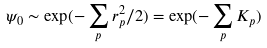<formula> <loc_0><loc_0><loc_500><loc_500>\psi _ { 0 } \sim \exp ( - \sum _ { p } r _ { p } ^ { 2 } / 2 ) = \exp ( - \sum _ { p } K _ { p } )</formula> 